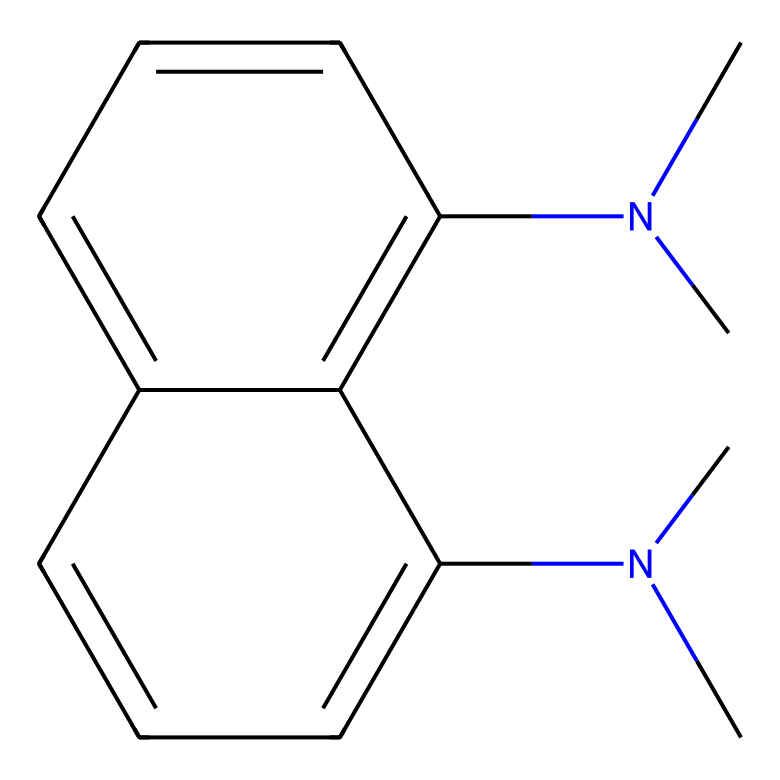What is the chemical name of the compound represented by this SMILES? The SMILES indicates the presence of two dimethylamino groups attached to a naphthalene ring, leading to the name "1,8-bis(dimethylamino)naphthalene".
Answer: 1,8-bis(dimethylamino)naphthalene How many nitrogen atoms are present in this compound? The structure shows two dimethylamino groups, each contributing one nitrogen atom, for a total of two nitrogen atoms in the compound.
Answer: 2 What type of chemical is 1,8-bis(dimethylamino)naphthalene classified as? This compound is classified as a superbases due to the presence of the electron-rich nitrogen atoms that can strongly deprotonate acids.
Answer: superbase What part of the structure contributes to the strong basicity of this compound? The dimethylamino groups contain nitrogen atoms with a lone pair of electrons, which allows the compound to accept protons readily, contributing to its basicity.
Answer: dimethylamino groups How many carbon atoms are present in this molecule? Counting the carbon atoms from both the naphthalene ring and the dimethylamino groups, there are a total of 13 carbon atoms in the compound.
Answer: 13 